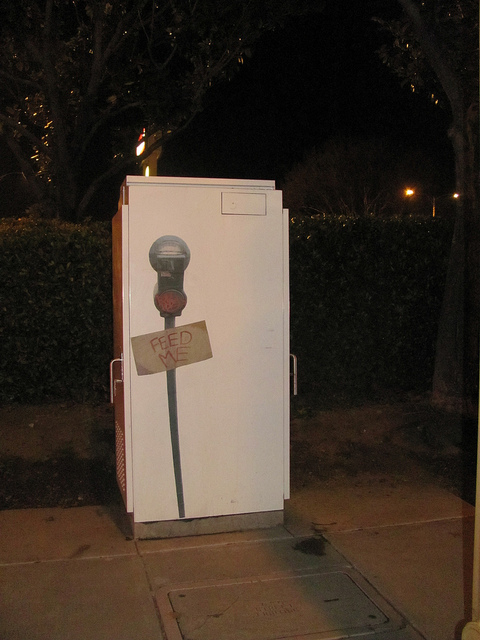Please identify all text content in this image. FEED ME 